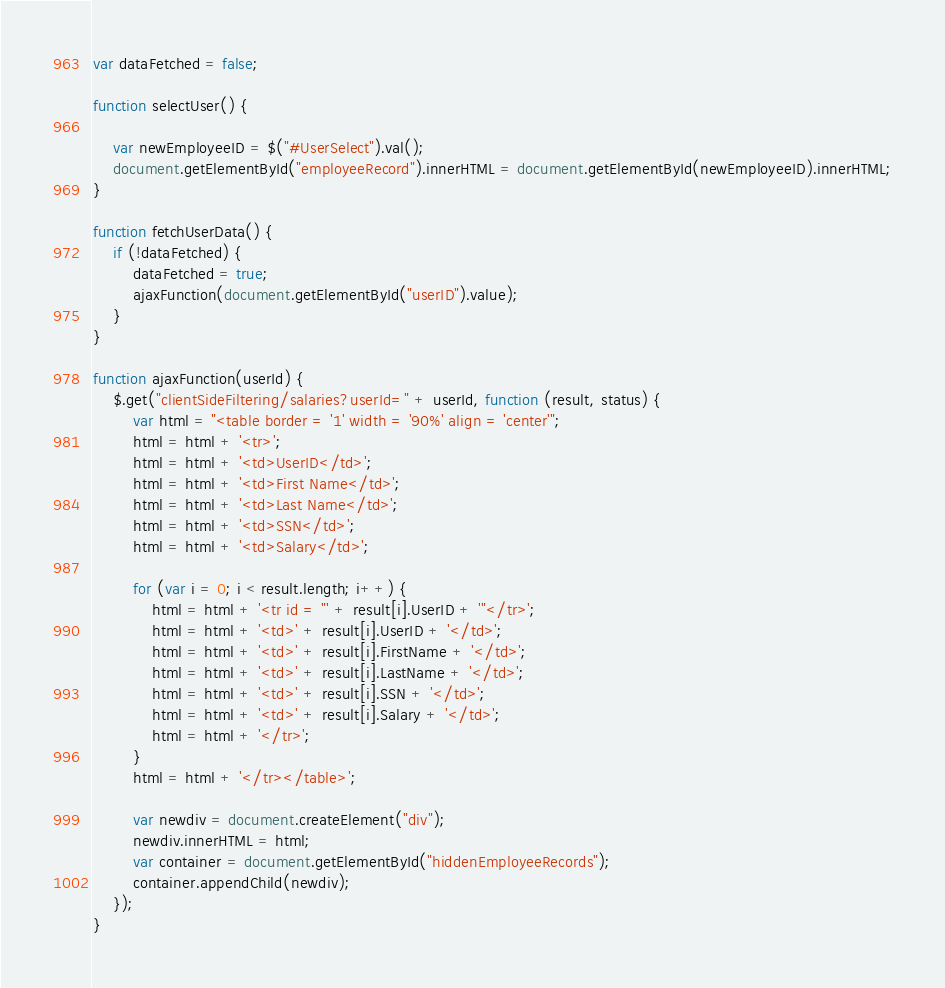Convert code to text. <code><loc_0><loc_0><loc_500><loc_500><_JavaScript_>var dataFetched = false;

function selectUser() {

    var newEmployeeID = $("#UserSelect").val();
    document.getElementById("employeeRecord").innerHTML = document.getElementById(newEmployeeID).innerHTML;
}

function fetchUserData() {
    if (!dataFetched) {
        dataFetched = true;
        ajaxFunction(document.getElementById("userID").value);
    }
}

function ajaxFunction(userId) {
    $.get("clientSideFiltering/salaries?userId=" + userId, function (result, status) {
        var html = "<table border = '1' width = '90%' align = 'center'";
        html = html + '<tr>';
        html = html + '<td>UserID</td>';
        html = html + '<td>First Name</td>';
        html = html + '<td>Last Name</td>';
        html = html + '<td>SSN</td>';
        html = html + '<td>Salary</td>';

        for (var i = 0; i < result.length; i++) {
            html = html + '<tr id = "' + result[i].UserID + '"</tr>';
            html = html + '<td>' + result[i].UserID + '</td>';
            html = html + '<td>' + result[i].FirstName + '</td>';
            html = html + '<td>' + result[i].LastName + '</td>';
            html = html + '<td>' + result[i].SSN + '</td>';
            html = html + '<td>' + result[i].Salary + '</td>';
            html = html + '</tr>';
        }
        html = html + '</tr></table>';

        var newdiv = document.createElement("div");
        newdiv.innerHTML = html;
        var container = document.getElementById("hiddenEmployeeRecords");
        container.appendChild(newdiv);
    });
}</code> 